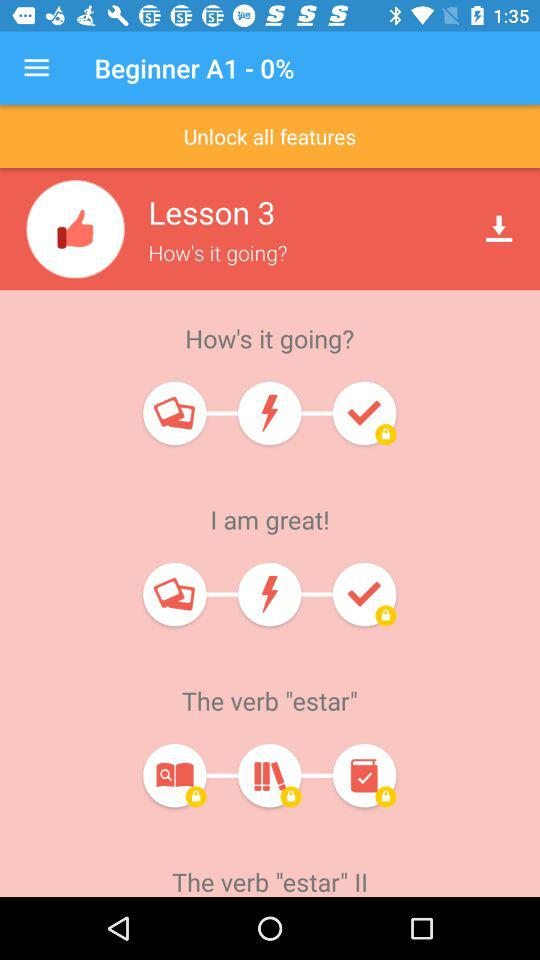How many lessons are there?
Answer the question using a single word or phrase. 3 